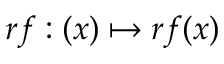Convert formula to latex. <formula><loc_0><loc_0><loc_500><loc_500>r f \colon ( x ) \mapsto r f ( x )</formula> 